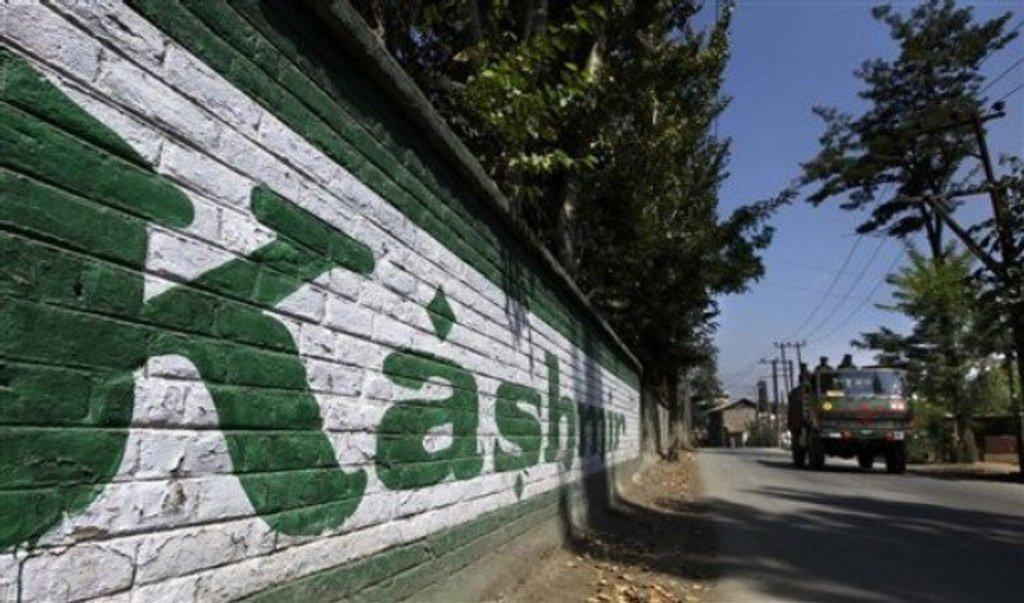Please provide a concise description of this image. In this image I can see a road and a wall with some text and some trees on both sides of the image. At the top of the image I can see the sky and I can see a vehicle and some people standing in the vehicle.  